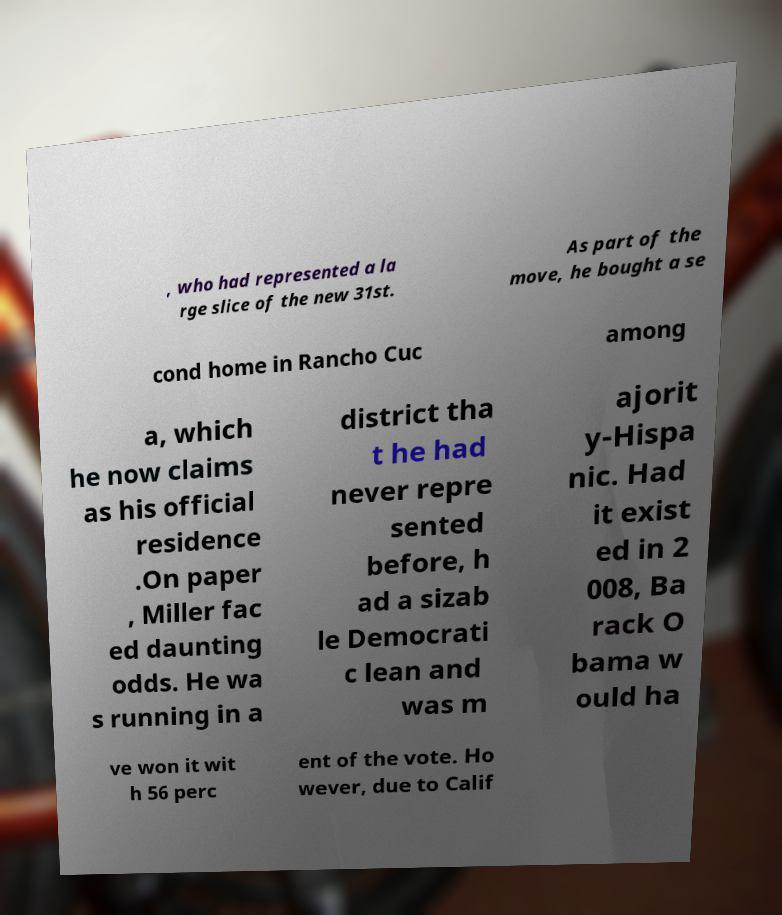Can you accurately transcribe the text from the provided image for me? , who had represented a la rge slice of the new 31st. As part of the move, he bought a se cond home in Rancho Cuc among a, which he now claims as his official residence .On paper , Miller fac ed daunting odds. He wa s running in a district tha t he had never repre sented before, h ad a sizab le Democrati c lean and was m ajorit y-Hispa nic. Had it exist ed in 2 008, Ba rack O bama w ould ha ve won it wit h 56 perc ent of the vote. Ho wever, due to Calif 